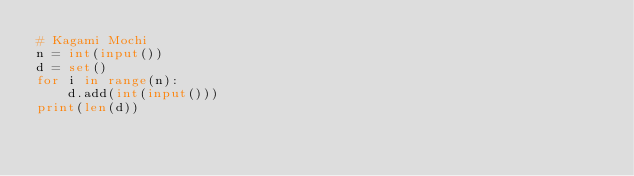<code> <loc_0><loc_0><loc_500><loc_500><_Python_># Kagami Mochi
n = int(input())
d = set()
for i in range(n):
    d.add(int(input()))
print(len(d))
</code> 